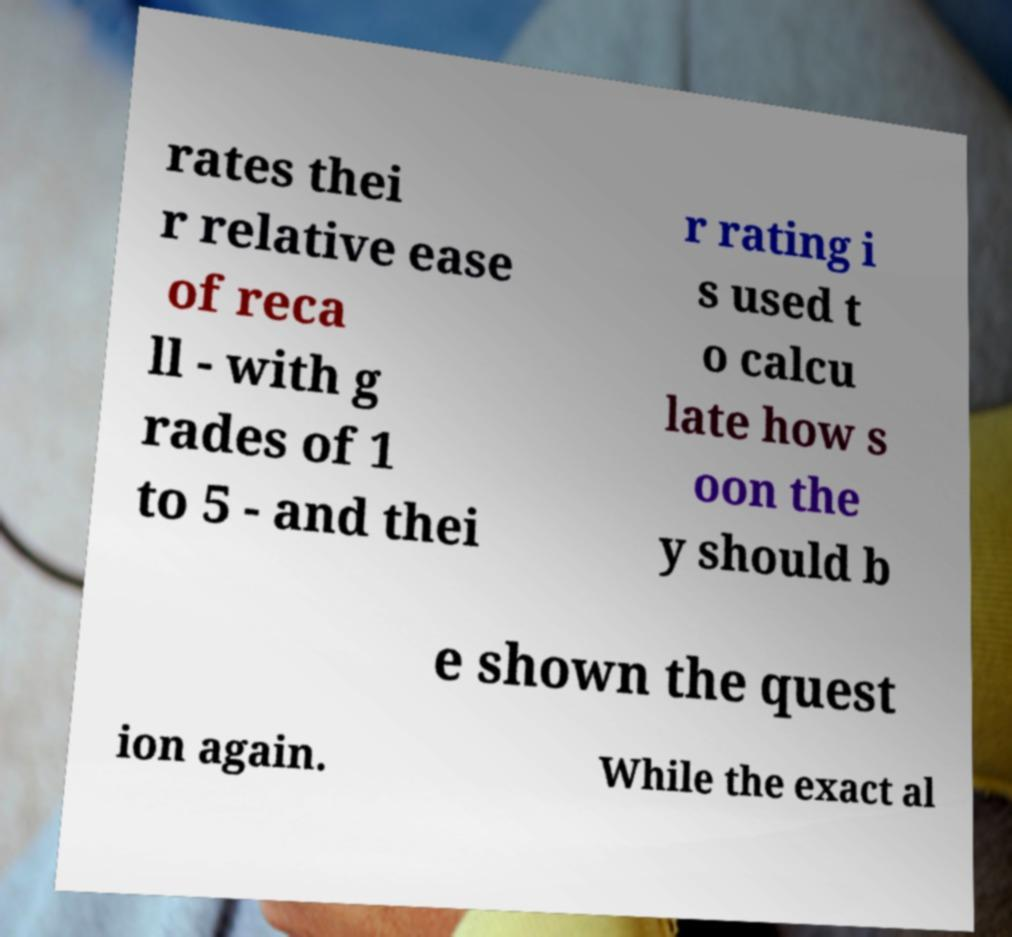Could you assist in decoding the text presented in this image and type it out clearly? rates thei r relative ease of reca ll - with g rades of 1 to 5 - and thei r rating i s used t o calcu late how s oon the y should b e shown the quest ion again. While the exact al 